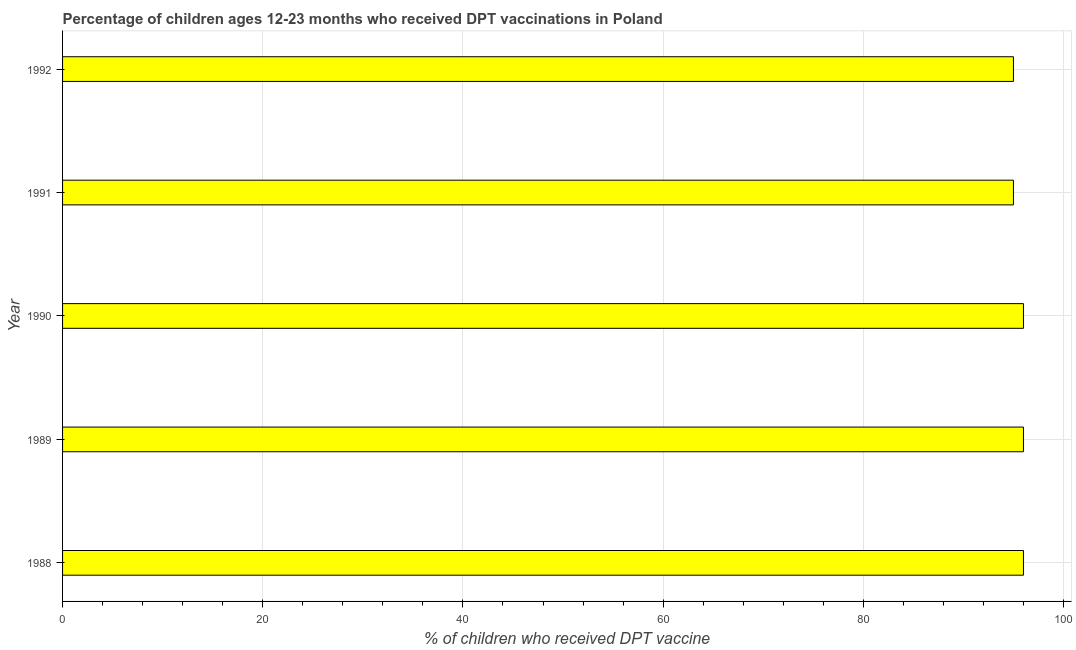Does the graph contain any zero values?
Keep it short and to the point. No. Does the graph contain grids?
Provide a succinct answer. Yes. What is the title of the graph?
Your answer should be compact. Percentage of children ages 12-23 months who received DPT vaccinations in Poland. What is the label or title of the X-axis?
Your answer should be compact. % of children who received DPT vaccine. What is the label or title of the Y-axis?
Make the answer very short. Year. What is the percentage of children who received dpt vaccine in 1990?
Provide a short and direct response. 96. Across all years, what is the maximum percentage of children who received dpt vaccine?
Provide a short and direct response. 96. In which year was the percentage of children who received dpt vaccine minimum?
Provide a short and direct response. 1991. What is the sum of the percentage of children who received dpt vaccine?
Make the answer very short. 478. What is the median percentage of children who received dpt vaccine?
Keep it short and to the point. 96. In how many years, is the percentage of children who received dpt vaccine greater than 8 %?
Offer a very short reply. 5. Do a majority of the years between 1990 and 1988 (inclusive) have percentage of children who received dpt vaccine greater than 32 %?
Make the answer very short. Yes. Is the percentage of children who received dpt vaccine in 1988 less than that in 1992?
Ensure brevity in your answer.  No. Is the sum of the percentage of children who received dpt vaccine in 1988 and 1992 greater than the maximum percentage of children who received dpt vaccine across all years?
Make the answer very short. Yes. What is the difference between the highest and the lowest percentage of children who received dpt vaccine?
Provide a short and direct response. 1. In how many years, is the percentage of children who received dpt vaccine greater than the average percentage of children who received dpt vaccine taken over all years?
Your answer should be compact. 3. Are all the bars in the graph horizontal?
Keep it short and to the point. Yes. How many years are there in the graph?
Keep it short and to the point. 5. What is the % of children who received DPT vaccine of 1988?
Keep it short and to the point. 96. What is the % of children who received DPT vaccine in 1989?
Provide a succinct answer. 96. What is the % of children who received DPT vaccine of 1990?
Your response must be concise. 96. What is the % of children who received DPT vaccine in 1991?
Offer a terse response. 95. What is the % of children who received DPT vaccine in 1992?
Offer a very short reply. 95. What is the difference between the % of children who received DPT vaccine in 1988 and 1989?
Give a very brief answer. 0. What is the difference between the % of children who received DPT vaccine in 1988 and 1990?
Keep it short and to the point. 0. What is the difference between the % of children who received DPT vaccine in 1989 and 1990?
Provide a short and direct response. 0. What is the difference between the % of children who received DPT vaccine in 1989 and 1992?
Keep it short and to the point. 1. What is the difference between the % of children who received DPT vaccine in 1991 and 1992?
Provide a short and direct response. 0. What is the ratio of the % of children who received DPT vaccine in 1988 to that in 1990?
Offer a very short reply. 1. What is the ratio of the % of children who received DPT vaccine in 1988 to that in 1991?
Make the answer very short. 1.01. What is the ratio of the % of children who received DPT vaccine in 1989 to that in 1992?
Provide a succinct answer. 1.01. 